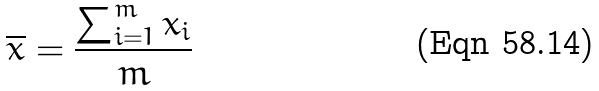<formula> <loc_0><loc_0><loc_500><loc_500>\overline { x } = \frac { \sum _ { i = 1 } ^ { m } x _ { i } } { m }</formula> 